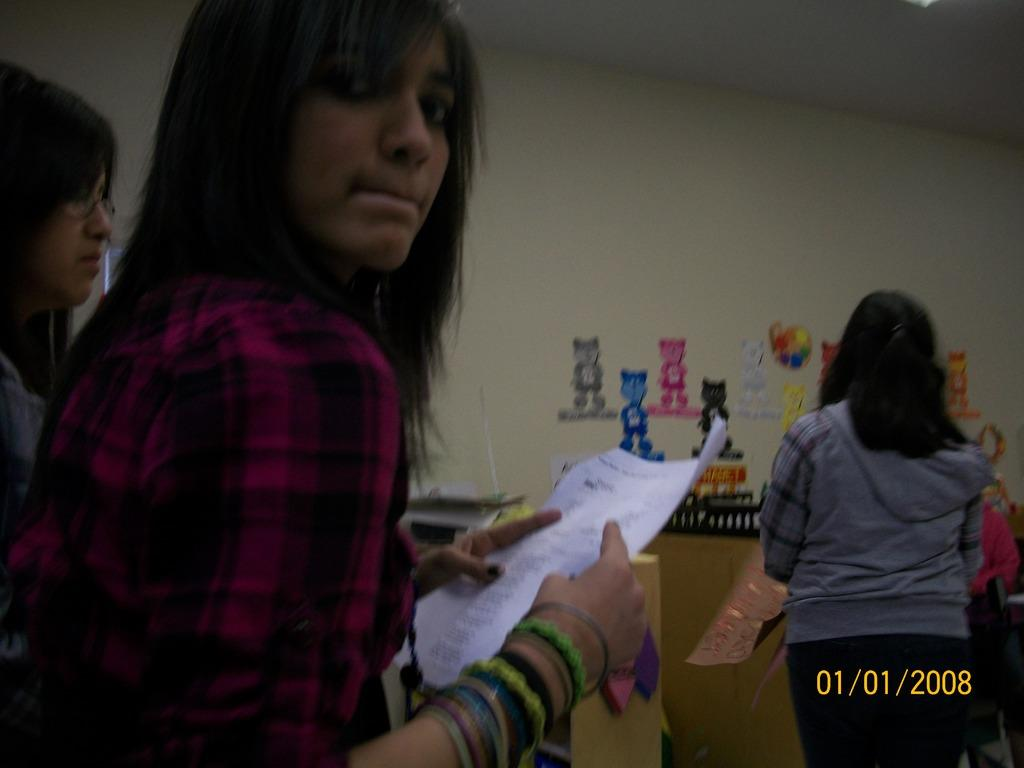<image>
Offer a succinct explanation of the picture presented. a girl wearing a purple flannel shirt was taken on January 1, 2008 